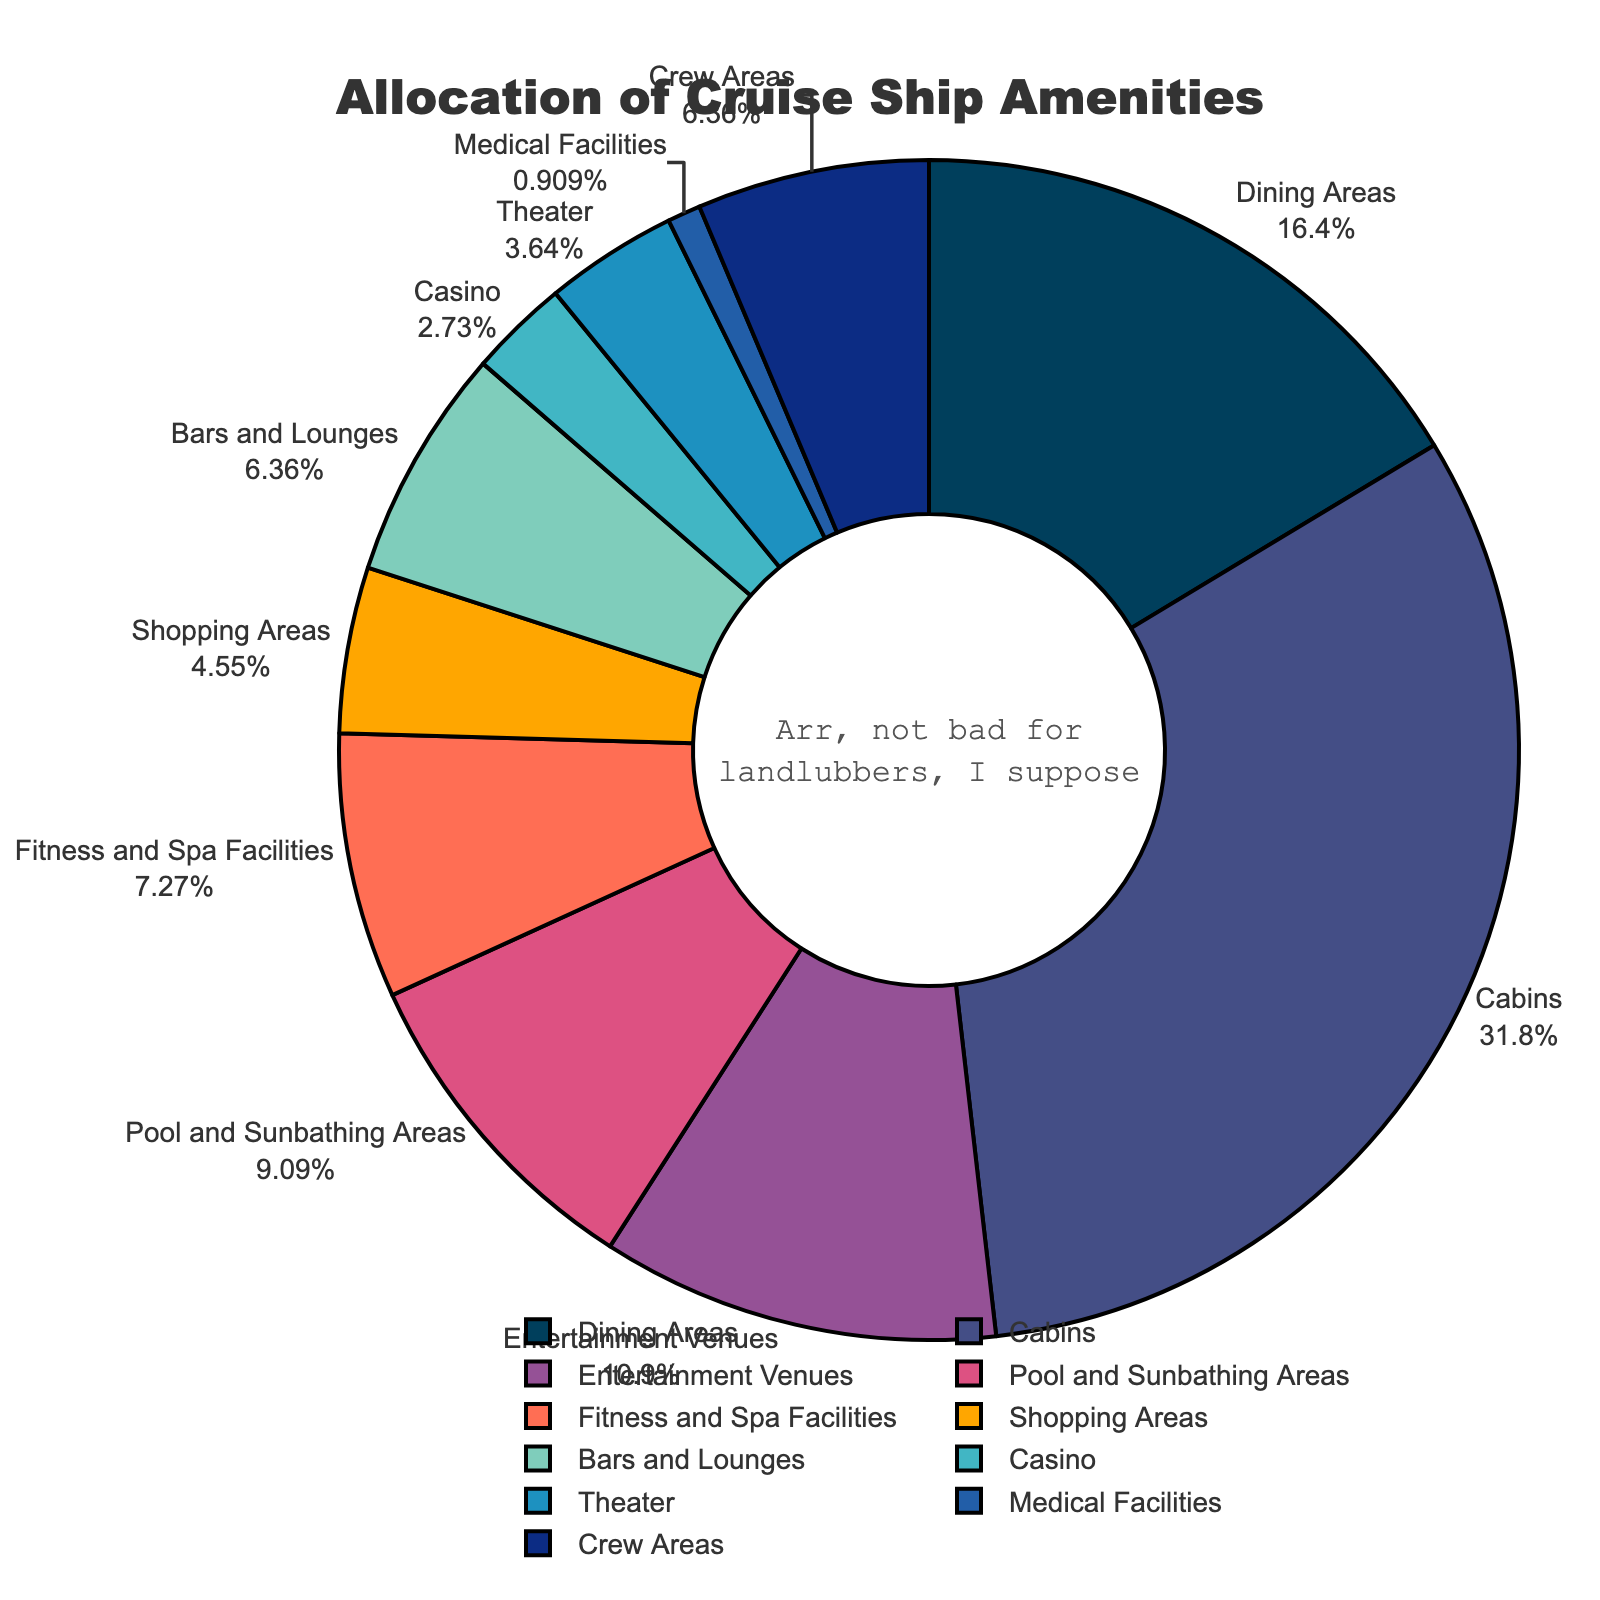What percentage of the ship's deck space is allocated to entertainment venues and theaters combined? To find the total percentage allocated to entertainment venues and theaters, add the percentage for entertainment venues (12%) to the percentage for theaters (4%). That gives 12% + 4% = 16%.
Answer: 16% Which deck space allocation is greater: bars and lounges or medical facilities? Compare the percentages of bars and lounges (7%) with medical facilities (1%). Since 7% is greater than 1%, bars and lounges have a greater allocation.
Answer: Bars and Lounges What is the difference in deck space allocation between cabins and dining areas? Subtract the percentage of dining areas (18%) from the percentage of cabins (35%). That gives 35% - 18% = 17%.
Answer: 17% What deck space category occupies the 3rd largest allocation? Looking at the percentages, the largest allocation is cabins (35%), followed by dining areas (18%), then entertainment venues (12%). So, entertainment venues occupy the 3rd largest allocation.
Answer: Entertainment Venues If you combine the allocation for fitness and spa facilities and shopping areas, does it exceed the allocation for pool and sunbathing areas? Add the percentages for fitness and spa facilities (8%) and shopping areas (5%) which equals 8% + 5% = 13%. Compare this with pool and sunbathing areas (10%). 13% is greater than 10%, so they do exceed the allocation for pool and sunbathing areas.
Answer: Yes Which color represents the allocation for the theater? From the color scheme, the color that represents the theater is light blue (#1d91c0 in hexadecimal coding, but translated visually it's a light blue color).
Answer: Light Blue 